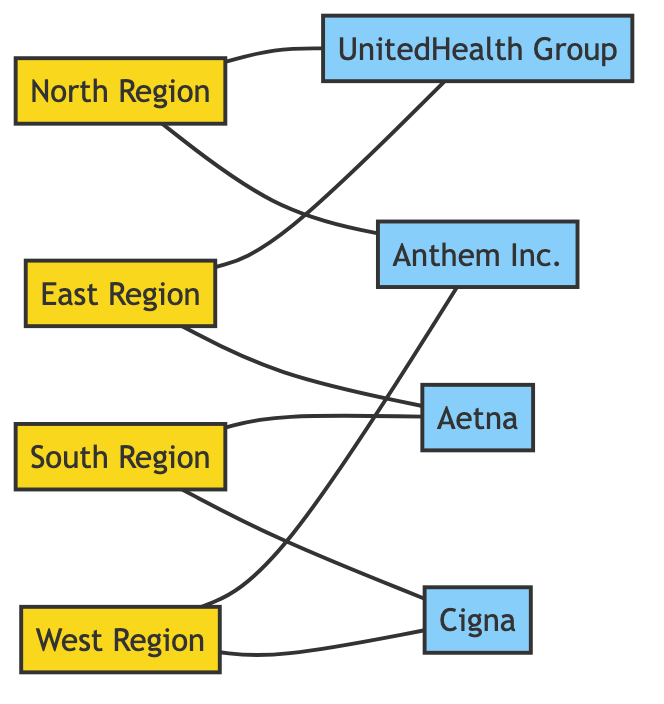What are the regions represented in the diagram? The diagram includes four nodes labeled "North Region," "South Region," "East Region," and "West Region." These are categorized as regions in the graph.
Answer: North Region, South Region, East Region, West Region Which insurance provider is connected to the South Region? The diagram shows connections from the South Region to two insurance providers: "Aetna" and "Cigna." Therefore, both are connected, but the question specifies one.
Answer: Aetna How many total edges are present in the diagram? The diagram contains a total of eight edges connecting various regions to insurance providers. Counting all the connections listed confirms this total.
Answer: 8 Which region is connected to UnitedHealth Group? The North Region and the East Region are both connected to UnitedHealth Group in the diagram. Therefore, the North Region is one of the connected regions.
Answer: North Region Which insurance providers are connected to the West Region? The West Region has connections to both "Anthem Inc." and "Cigna," indicating that these two are linked to that region.
Answer: Anthem Inc., Cigna How many regions are linked to UnitedHealth Group? The diagram indicates that UnitedHealth Group is connected to two regions: the North Region and the East Region, hence effectively linking them.
Answer: 2 Which insurance provider is connected to the most regions? By examining the connections, it is evident that UnitedHealth Group and Anthem Inc. are each connected to two regions, making them the providers that connect to the most regions.
Answer: UnitedHealth Group, Anthem Inc Is there a region connected to all insurance providers? Analyzing the diagram, no single region appears to connect with all four insurance providers; each region connects to two providers, but no overlap exists for all four.
Answer: No 